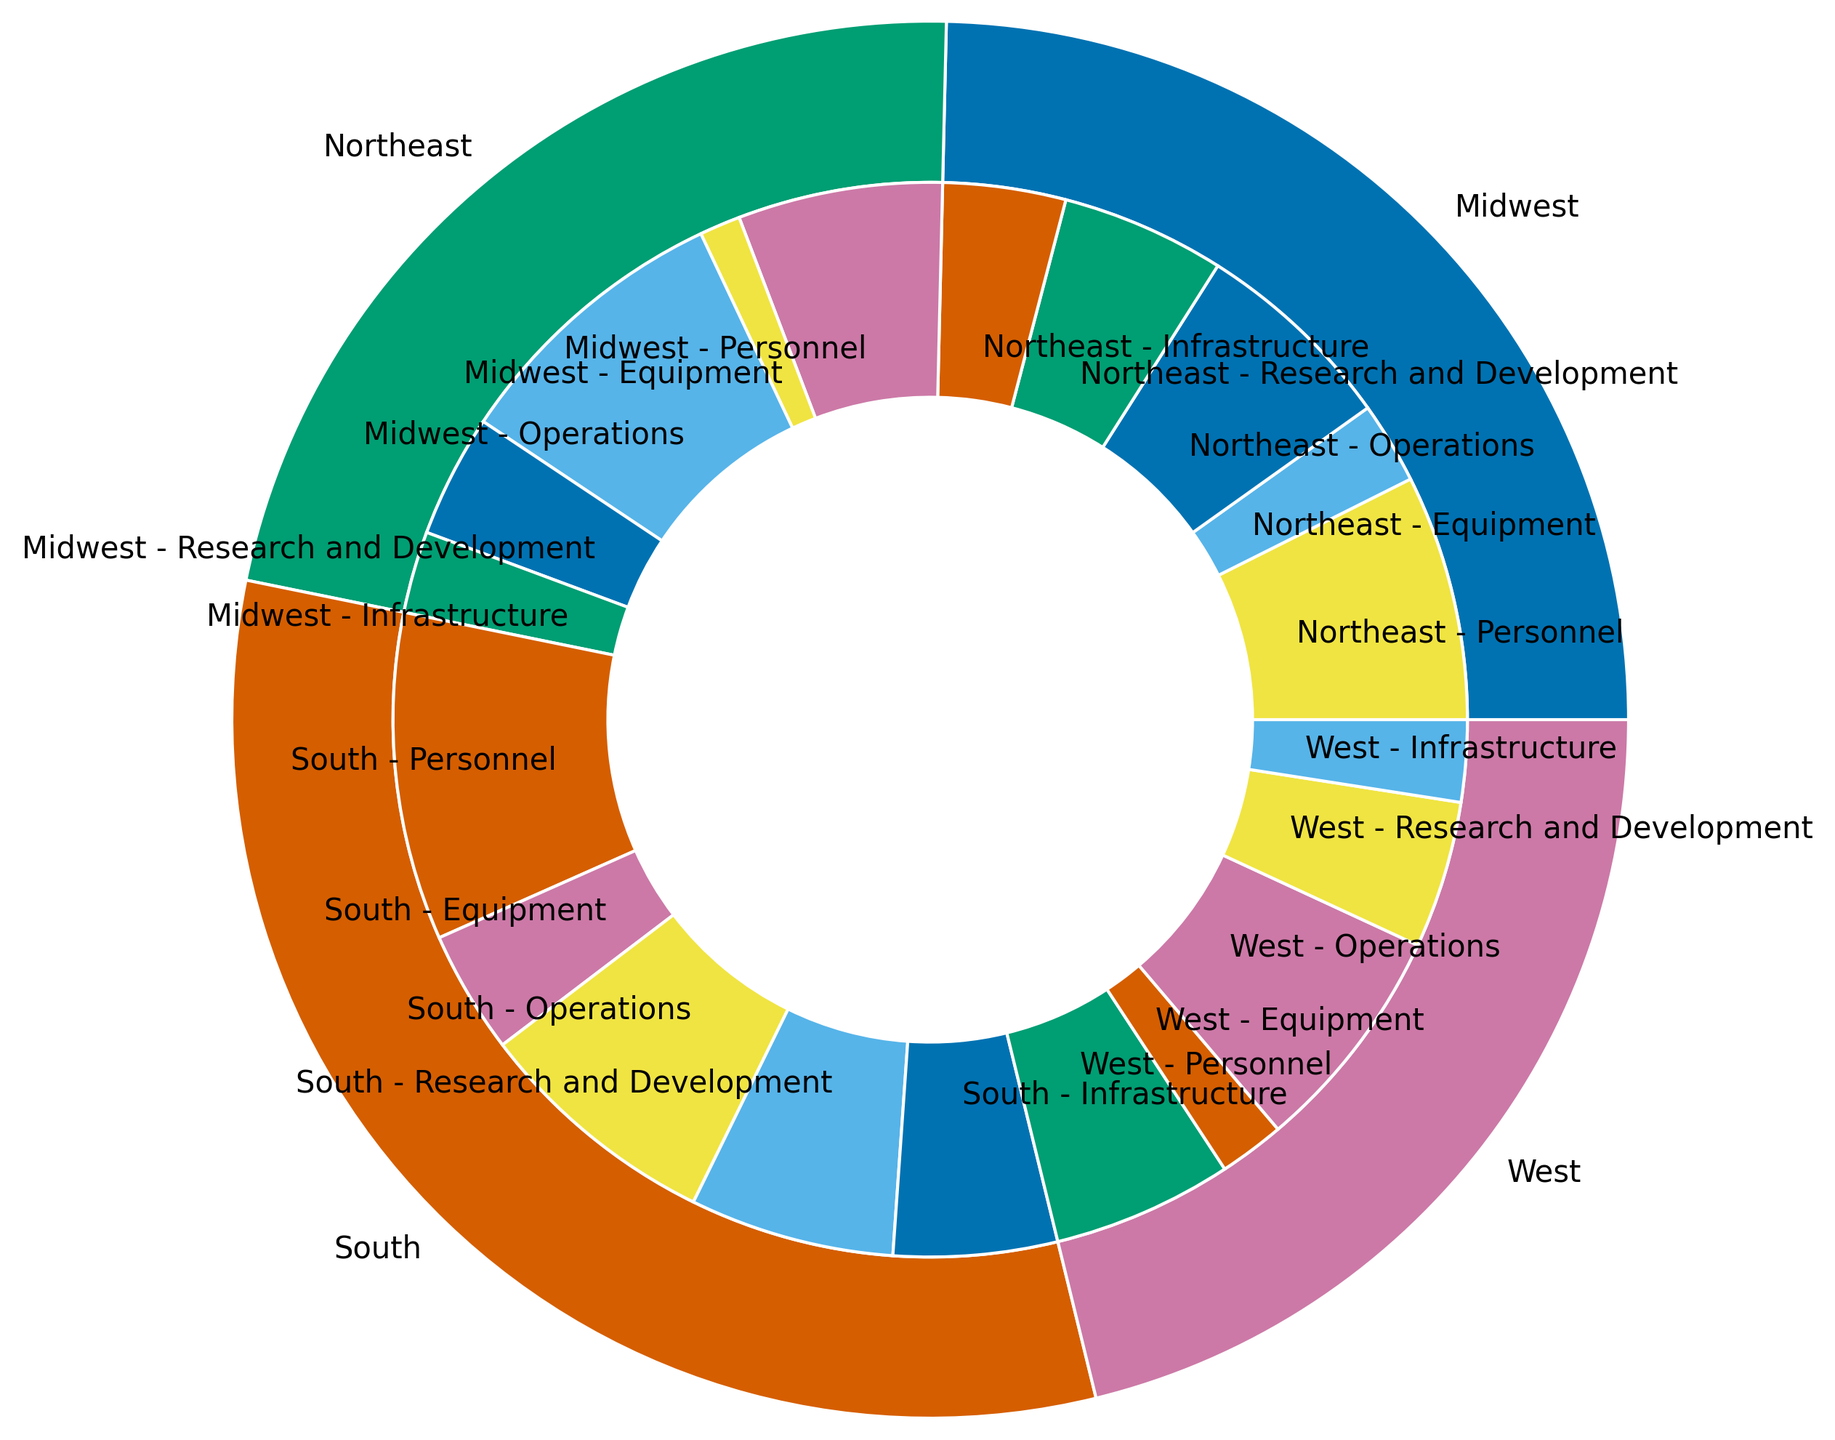Which region has the highest total national defense spending? The largest outer segment represents the South region. By comparing all outer segments, the South region appears to have the highest total amount of spending.
Answer: South Which region allocates the most funds for Personnel? The inner segment labeled "South - Personnel" is the larger slice compared to the same expenditure type in other regions.
Answer: South How much more is spent on Equipment in the South compared to the Northeast? The inner segment labeled "South - Equipment" is larger than the one labeled "Northeast - Equipment." The South spends 40 while the Northeast spends 25. The difference is 40 - 25 = 15.
Answer: 15 Which region spends the least amount on Infrastructure? By comparing the inner segments labeled with "Infrastructure," the Northeast has the smallest segment.
Answer: Northeast What is the total amount spent on Research and Development across all regions? Sum the amounts from all regions for Research and Development: 10 (Northeast) + 15 (Midwest) + 20 (South) + 10 (West) = 55.
Answer: 55 Compare the total spending on Operations between the Midwest and the West. Which one is higher? By evaluating the inner segments labeled "Operations," the West (28) is slightly higher than the Midwest (25).
Answer: West In terms of Equipment spending, how does the Northeast compare to the Midwest? The inner segment labeled "Midwest - Equipment" (30) is larger than the one labeled "Northeast - Equipment" (25).
Answer: Midwest Which expenditure type in the Northeast region receives the highest funding? By comparing the inner segments in the Northeast, the "Operations" segment is the largest.
Answer: Operations How does the total national defense spending in the Midwest compare to that in the West? By examining the outer segments, the Midwest (85) is higher than the West (78).
Answer: Midwest If the total budget were to be evenly distributed among all regions and expenditure types, what would be the average amount allocated to each segment? Total budget is calculated by summing up all amounts: 15 + 25 + 35 + 20 + 30 + 25 + 25 + 40 + 30 + 18 + 22 + 28 + 10 + 15 + 20 + 10 + 5 + 10 + 15 + 8 = 396. There are 20 segments, so the average is 396 / 20 = 19.8.
Answer: 19.8 